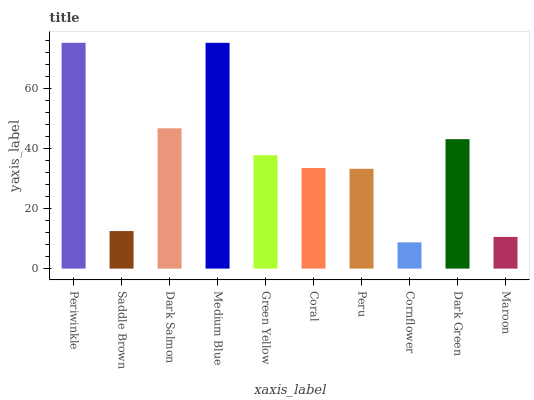Is Cornflower the minimum?
Answer yes or no. Yes. Is Periwinkle the maximum?
Answer yes or no. Yes. Is Saddle Brown the minimum?
Answer yes or no. No. Is Saddle Brown the maximum?
Answer yes or no. No. Is Periwinkle greater than Saddle Brown?
Answer yes or no. Yes. Is Saddle Brown less than Periwinkle?
Answer yes or no. Yes. Is Saddle Brown greater than Periwinkle?
Answer yes or no. No. Is Periwinkle less than Saddle Brown?
Answer yes or no. No. Is Green Yellow the high median?
Answer yes or no. Yes. Is Coral the low median?
Answer yes or no. Yes. Is Coral the high median?
Answer yes or no. No. Is Maroon the low median?
Answer yes or no. No. 